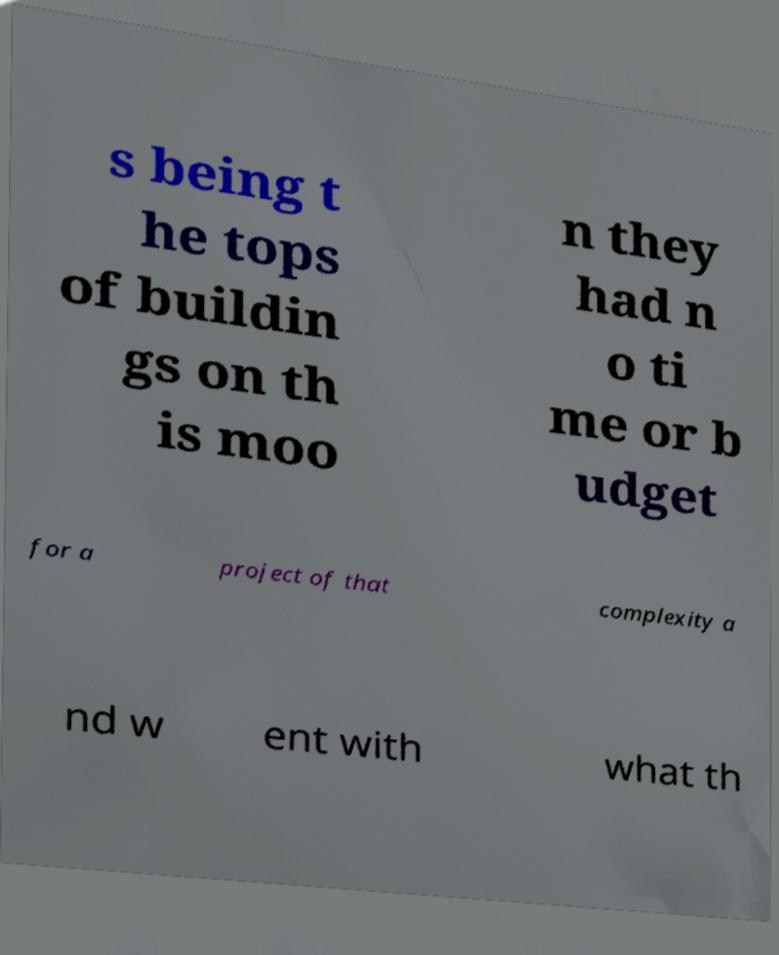There's text embedded in this image that I need extracted. Can you transcribe it verbatim? s being t he tops of buildin gs on th is moo n they had n o ti me or b udget for a project of that complexity a nd w ent with what th 